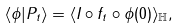Convert formula to latex. <formula><loc_0><loc_0><loc_500><loc_500>\langle \phi | P _ { t } \rangle = \langle I \circ f _ { t } \circ \phi ( 0 ) \rangle _ { \mathbb { H } } ,</formula> 